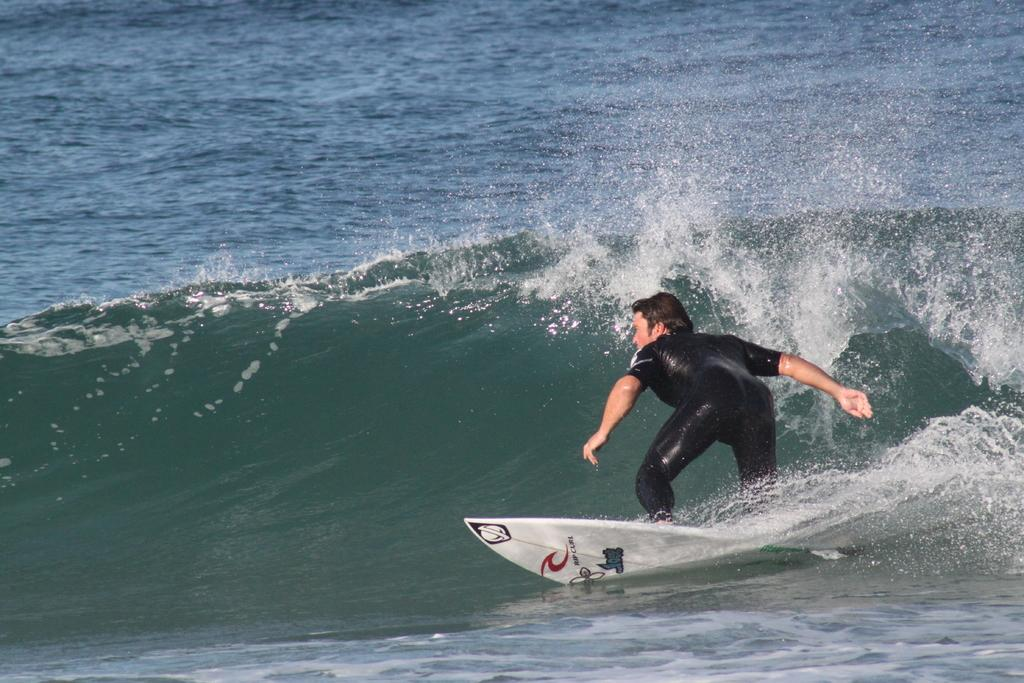What is the person in the image doing? The person is surfing. What color is the surfing board? The surfing board is white. What is the person wearing while surfing? The person is wearing a black suit. What can be seen in the background of the image? There is water visible in the image. What type of arch can be seen in the background of the image? There is no arch present in the image; it features a person surfing on a white surfing board in water. 